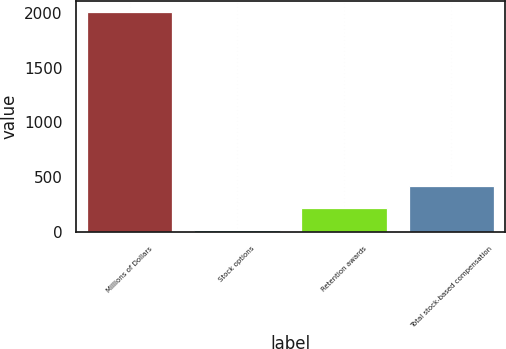<chart> <loc_0><loc_0><loc_500><loc_500><bar_chart><fcel>Millions of Dollars<fcel>Stock options<fcel>Retention awards<fcel>Total stock-based compensation<nl><fcel>2008<fcel>25<fcel>223.3<fcel>421.6<nl></chart> 